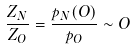Convert formula to latex. <formula><loc_0><loc_0><loc_500><loc_500>\frac { Z _ { N } } { Z _ { O } } = \frac { p _ { N } ( O ) } { p _ { O } } \sim O</formula> 